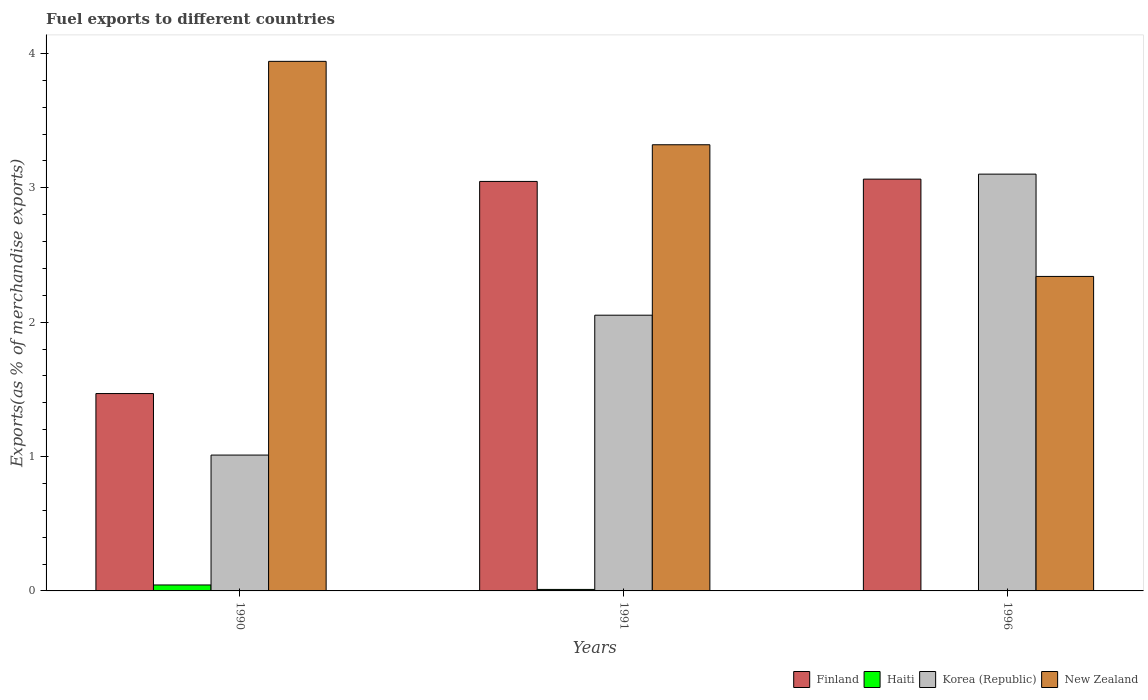How many different coloured bars are there?
Offer a very short reply. 4. How many groups of bars are there?
Provide a short and direct response. 3. Are the number of bars on each tick of the X-axis equal?
Offer a terse response. Yes. How many bars are there on the 1st tick from the right?
Offer a very short reply. 4. What is the label of the 1st group of bars from the left?
Make the answer very short. 1990. In how many cases, is the number of bars for a given year not equal to the number of legend labels?
Your answer should be very brief. 0. What is the percentage of exports to different countries in New Zealand in 1991?
Make the answer very short. 3.32. Across all years, what is the maximum percentage of exports to different countries in Finland?
Make the answer very short. 3.06. Across all years, what is the minimum percentage of exports to different countries in Haiti?
Provide a succinct answer. 1.15759498066816e-5. What is the total percentage of exports to different countries in New Zealand in the graph?
Your answer should be very brief. 9.6. What is the difference between the percentage of exports to different countries in Finland in 1990 and that in 1996?
Ensure brevity in your answer.  -1.6. What is the difference between the percentage of exports to different countries in Korea (Republic) in 1991 and the percentage of exports to different countries in Haiti in 1990?
Give a very brief answer. 2.01. What is the average percentage of exports to different countries in New Zealand per year?
Your answer should be compact. 3.2. In the year 1990, what is the difference between the percentage of exports to different countries in Haiti and percentage of exports to different countries in Finland?
Provide a succinct answer. -1.42. In how many years, is the percentage of exports to different countries in Korea (Republic) greater than 1.6 %?
Make the answer very short. 2. What is the ratio of the percentage of exports to different countries in Haiti in 1990 to that in 1991?
Keep it short and to the point. 4. Is the difference between the percentage of exports to different countries in Haiti in 1991 and 1996 greater than the difference between the percentage of exports to different countries in Finland in 1991 and 1996?
Offer a very short reply. Yes. What is the difference between the highest and the second highest percentage of exports to different countries in New Zealand?
Provide a short and direct response. 0.62. What is the difference between the highest and the lowest percentage of exports to different countries in New Zealand?
Ensure brevity in your answer.  1.6. Is the sum of the percentage of exports to different countries in Haiti in 1991 and 1996 greater than the maximum percentage of exports to different countries in Korea (Republic) across all years?
Offer a very short reply. No. What does the 3rd bar from the left in 1991 represents?
Ensure brevity in your answer.  Korea (Republic). What does the 2nd bar from the right in 1996 represents?
Provide a succinct answer. Korea (Republic). Is it the case that in every year, the sum of the percentage of exports to different countries in Haiti and percentage of exports to different countries in New Zealand is greater than the percentage of exports to different countries in Korea (Republic)?
Your answer should be compact. No. Are all the bars in the graph horizontal?
Your answer should be very brief. No. How many years are there in the graph?
Make the answer very short. 3. What is the difference between two consecutive major ticks on the Y-axis?
Your response must be concise. 1. Does the graph contain any zero values?
Provide a succinct answer. No. How are the legend labels stacked?
Make the answer very short. Horizontal. What is the title of the graph?
Give a very brief answer. Fuel exports to different countries. What is the label or title of the X-axis?
Ensure brevity in your answer.  Years. What is the label or title of the Y-axis?
Your answer should be very brief. Exports(as % of merchandise exports). What is the Exports(as % of merchandise exports) of Finland in 1990?
Ensure brevity in your answer.  1.47. What is the Exports(as % of merchandise exports) in Haiti in 1990?
Provide a short and direct response. 0.04. What is the Exports(as % of merchandise exports) in Korea (Republic) in 1990?
Keep it short and to the point. 1.01. What is the Exports(as % of merchandise exports) of New Zealand in 1990?
Your response must be concise. 3.94. What is the Exports(as % of merchandise exports) in Finland in 1991?
Offer a terse response. 3.05. What is the Exports(as % of merchandise exports) in Haiti in 1991?
Your response must be concise. 0.01. What is the Exports(as % of merchandise exports) in Korea (Republic) in 1991?
Offer a terse response. 2.05. What is the Exports(as % of merchandise exports) of New Zealand in 1991?
Offer a terse response. 3.32. What is the Exports(as % of merchandise exports) of Finland in 1996?
Offer a very short reply. 3.06. What is the Exports(as % of merchandise exports) of Haiti in 1996?
Ensure brevity in your answer.  1.15759498066816e-5. What is the Exports(as % of merchandise exports) of Korea (Republic) in 1996?
Your response must be concise. 3.1. What is the Exports(as % of merchandise exports) in New Zealand in 1996?
Provide a short and direct response. 2.34. Across all years, what is the maximum Exports(as % of merchandise exports) of Finland?
Make the answer very short. 3.06. Across all years, what is the maximum Exports(as % of merchandise exports) in Haiti?
Give a very brief answer. 0.04. Across all years, what is the maximum Exports(as % of merchandise exports) in Korea (Republic)?
Offer a very short reply. 3.1. Across all years, what is the maximum Exports(as % of merchandise exports) of New Zealand?
Provide a succinct answer. 3.94. Across all years, what is the minimum Exports(as % of merchandise exports) of Finland?
Provide a short and direct response. 1.47. Across all years, what is the minimum Exports(as % of merchandise exports) of Haiti?
Your answer should be compact. 1.15759498066816e-5. Across all years, what is the minimum Exports(as % of merchandise exports) of Korea (Republic)?
Give a very brief answer. 1.01. Across all years, what is the minimum Exports(as % of merchandise exports) of New Zealand?
Your answer should be very brief. 2.34. What is the total Exports(as % of merchandise exports) of Finland in the graph?
Your answer should be very brief. 7.58. What is the total Exports(as % of merchandise exports) in Haiti in the graph?
Offer a terse response. 0.06. What is the total Exports(as % of merchandise exports) in Korea (Republic) in the graph?
Offer a very short reply. 6.16. What is the total Exports(as % of merchandise exports) of New Zealand in the graph?
Give a very brief answer. 9.6. What is the difference between the Exports(as % of merchandise exports) in Finland in 1990 and that in 1991?
Your answer should be compact. -1.58. What is the difference between the Exports(as % of merchandise exports) of Haiti in 1990 and that in 1991?
Provide a short and direct response. 0.03. What is the difference between the Exports(as % of merchandise exports) in Korea (Republic) in 1990 and that in 1991?
Offer a very short reply. -1.04. What is the difference between the Exports(as % of merchandise exports) of New Zealand in 1990 and that in 1991?
Your response must be concise. 0.62. What is the difference between the Exports(as % of merchandise exports) in Finland in 1990 and that in 1996?
Provide a succinct answer. -1.6. What is the difference between the Exports(as % of merchandise exports) in Haiti in 1990 and that in 1996?
Provide a succinct answer. 0.04. What is the difference between the Exports(as % of merchandise exports) in Korea (Republic) in 1990 and that in 1996?
Keep it short and to the point. -2.09. What is the difference between the Exports(as % of merchandise exports) of New Zealand in 1990 and that in 1996?
Your response must be concise. 1.6. What is the difference between the Exports(as % of merchandise exports) in Finland in 1991 and that in 1996?
Make the answer very short. -0.02. What is the difference between the Exports(as % of merchandise exports) of Haiti in 1991 and that in 1996?
Offer a terse response. 0.01. What is the difference between the Exports(as % of merchandise exports) of Korea (Republic) in 1991 and that in 1996?
Provide a succinct answer. -1.05. What is the difference between the Exports(as % of merchandise exports) in New Zealand in 1991 and that in 1996?
Your answer should be very brief. 0.98. What is the difference between the Exports(as % of merchandise exports) of Finland in 1990 and the Exports(as % of merchandise exports) of Haiti in 1991?
Your answer should be compact. 1.46. What is the difference between the Exports(as % of merchandise exports) in Finland in 1990 and the Exports(as % of merchandise exports) in Korea (Republic) in 1991?
Your answer should be very brief. -0.58. What is the difference between the Exports(as % of merchandise exports) in Finland in 1990 and the Exports(as % of merchandise exports) in New Zealand in 1991?
Provide a short and direct response. -1.85. What is the difference between the Exports(as % of merchandise exports) in Haiti in 1990 and the Exports(as % of merchandise exports) in Korea (Republic) in 1991?
Keep it short and to the point. -2.01. What is the difference between the Exports(as % of merchandise exports) of Haiti in 1990 and the Exports(as % of merchandise exports) of New Zealand in 1991?
Provide a short and direct response. -3.28. What is the difference between the Exports(as % of merchandise exports) in Korea (Republic) in 1990 and the Exports(as % of merchandise exports) in New Zealand in 1991?
Provide a succinct answer. -2.31. What is the difference between the Exports(as % of merchandise exports) in Finland in 1990 and the Exports(as % of merchandise exports) in Haiti in 1996?
Provide a succinct answer. 1.47. What is the difference between the Exports(as % of merchandise exports) in Finland in 1990 and the Exports(as % of merchandise exports) in Korea (Republic) in 1996?
Ensure brevity in your answer.  -1.63. What is the difference between the Exports(as % of merchandise exports) of Finland in 1990 and the Exports(as % of merchandise exports) of New Zealand in 1996?
Ensure brevity in your answer.  -0.87. What is the difference between the Exports(as % of merchandise exports) in Haiti in 1990 and the Exports(as % of merchandise exports) in Korea (Republic) in 1996?
Your answer should be very brief. -3.06. What is the difference between the Exports(as % of merchandise exports) in Haiti in 1990 and the Exports(as % of merchandise exports) in New Zealand in 1996?
Keep it short and to the point. -2.3. What is the difference between the Exports(as % of merchandise exports) of Korea (Republic) in 1990 and the Exports(as % of merchandise exports) of New Zealand in 1996?
Provide a succinct answer. -1.33. What is the difference between the Exports(as % of merchandise exports) of Finland in 1991 and the Exports(as % of merchandise exports) of Haiti in 1996?
Provide a short and direct response. 3.05. What is the difference between the Exports(as % of merchandise exports) in Finland in 1991 and the Exports(as % of merchandise exports) in Korea (Republic) in 1996?
Offer a very short reply. -0.05. What is the difference between the Exports(as % of merchandise exports) of Finland in 1991 and the Exports(as % of merchandise exports) of New Zealand in 1996?
Your answer should be very brief. 0.71. What is the difference between the Exports(as % of merchandise exports) in Haiti in 1991 and the Exports(as % of merchandise exports) in Korea (Republic) in 1996?
Give a very brief answer. -3.09. What is the difference between the Exports(as % of merchandise exports) of Haiti in 1991 and the Exports(as % of merchandise exports) of New Zealand in 1996?
Keep it short and to the point. -2.33. What is the difference between the Exports(as % of merchandise exports) in Korea (Republic) in 1991 and the Exports(as % of merchandise exports) in New Zealand in 1996?
Keep it short and to the point. -0.29. What is the average Exports(as % of merchandise exports) of Finland per year?
Offer a terse response. 2.53. What is the average Exports(as % of merchandise exports) in Haiti per year?
Give a very brief answer. 0.02. What is the average Exports(as % of merchandise exports) of Korea (Republic) per year?
Ensure brevity in your answer.  2.06. What is the average Exports(as % of merchandise exports) in New Zealand per year?
Your response must be concise. 3.2. In the year 1990, what is the difference between the Exports(as % of merchandise exports) in Finland and Exports(as % of merchandise exports) in Haiti?
Offer a terse response. 1.42. In the year 1990, what is the difference between the Exports(as % of merchandise exports) of Finland and Exports(as % of merchandise exports) of Korea (Republic)?
Ensure brevity in your answer.  0.46. In the year 1990, what is the difference between the Exports(as % of merchandise exports) in Finland and Exports(as % of merchandise exports) in New Zealand?
Give a very brief answer. -2.47. In the year 1990, what is the difference between the Exports(as % of merchandise exports) of Haiti and Exports(as % of merchandise exports) of Korea (Republic)?
Make the answer very short. -0.97. In the year 1990, what is the difference between the Exports(as % of merchandise exports) in Haiti and Exports(as % of merchandise exports) in New Zealand?
Provide a short and direct response. -3.9. In the year 1990, what is the difference between the Exports(as % of merchandise exports) in Korea (Republic) and Exports(as % of merchandise exports) in New Zealand?
Provide a short and direct response. -2.93. In the year 1991, what is the difference between the Exports(as % of merchandise exports) of Finland and Exports(as % of merchandise exports) of Haiti?
Provide a succinct answer. 3.04. In the year 1991, what is the difference between the Exports(as % of merchandise exports) of Finland and Exports(as % of merchandise exports) of Korea (Republic)?
Offer a terse response. 1. In the year 1991, what is the difference between the Exports(as % of merchandise exports) in Finland and Exports(as % of merchandise exports) in New Zealand?
Offer a terse response. -0.27. In the year 1991, what is the difference between the Exports(as % of merchandise exports) in Haiti and Exports(as % of merchandise exports) in Korea (Republic)?
Provide a succinct answer. -2.04. In the year 1991, what is the difference between the Exports(as % of merchandise exports) in Haiti and Exports(as % of merchandise exports) in New Zealand?
Your answer should be compact. -3.31. In the year 1991, what is the difference between the Exports(as % of merchandise exports) of Korea (Republic) and Exports(as % of merchandise exports) of New Zealand?
Keep it short and to the point. -1.27. In the year 1996, what is the difference between the Exports(as % of merchandise exports) of Finland and Exports(as % of merchandise exports) of Haiti?
Offer a terse response. 3.06. In the year 1996, what is the difference between the Exports(as % of merchandise exports) in Finland and Exports(as % of merchandise exports) in Korea (Republic)?
Your answer should be very brief. -0.04. In the year 1996, what is the difference between the Exports(as % of merchandise exports) in Finland and Exports(as % of merchandise exports) in New Zealand?
Provide a short and direct response. 0.72. In the year 1996, what is the difference between the Exports(as % of merchandise exports) of Haiti and Exports(as % of merchandise exports) of Korea (Republic)?
Make the answer very short. -3.1. In the year 1996, what is the difference between the Exports(as % of merchandise exports) in Haiti and Exports(as % of merchandise exports) in New Zealand?
Your response must be concise. -2.34. In the year 1996, what is the difference between the Exports(as % of merchandise exports) in Korea (Republic) and Exports(as % of merchandise exports) in New Zealand?
Ensure brevity in your answer.  0.76. What is the ratio of the Exports(as % of merchandise exports) of Finland in 1990 to that in 1991?
Give a very brief answer. 0.48. What is the ratio of the Exports(as % of merchandise exports) in Haiti in 1990 to that in 1991?
Your response must be concise. 4. What is the ratio of the Exports(as % of merchandise exports) in Korea (Republic) in 1990 to that in 1991?
Your response must be concise. 0.49. What is the ratio of the Exports(as % of merchandise exports) in New Zealand in 1990 to that in 1991?
Your answer should be compact. 1.19. What is the ratio of the Exports(as % of merchandise exports) of Finland in 1990 to that in 1996?
Give a very brief answer. 0.48. What is the ratio of the Exports(as % of merchandise exports) of Haiti in 1990 to that in 1996?
Offer a terse response. 3831.78. What is the ratio of the Exports(as % of merchandise exports) of Korea (Republic) in 1990 to that in 1996?
Keep it short and to the point. 0.33. What is the ratio of the Exports(as % of merchandise exports) of New Zealand in 1990 to that in 1996?
Give a very brief answer. 1.68. What is the ratio of the Exports(as % of merchandise exports) in Haiti in 1991 to that in 1996?
Offer a very short reply. 957.84. What is the ratio of the Exports(as % of merchandise exports) of Korea (Republic) in 1991 to that in 1996?
Ensure brevity in your answer.  0.66. What is the ratio of the Exports(as % of merchandise exports) in New Zealand in 1991 to that in 1996?
Give a very brief answer. 1.42. What is the difference between the highest and the second highest Exports(as % of merchandise exports) in Finland?
Your answer should be compact. 0.02. What is the difference between the highest and the second highest Exports(as % of merchandise exports) in Korea (Republic)?
Your answer should be compact. 1.05. What is the difference between the highest and the second highest Exports(as % of merchandise exports) in New Zealand?
Provide a short and direct response. 0.62. What is the difference between the highest and the lowest Exports(as % of merchandise exports) of Finland?
Offer a very short reply. 1.6. What is the difference between the highest and the lowest Exports(as % of merchandise exports) of Haiti?
Provide a short and direct response. 0.04. What is the difference between the highest and the lowest Exports(as % of merchandise exports) of Korea (Republic)?
Your answer should be very brief. 2.09. What is the difference between the highest and the lowest Exports(as % of merchandise exports) in New Zealand?
Make the answer very short. 1.6. 